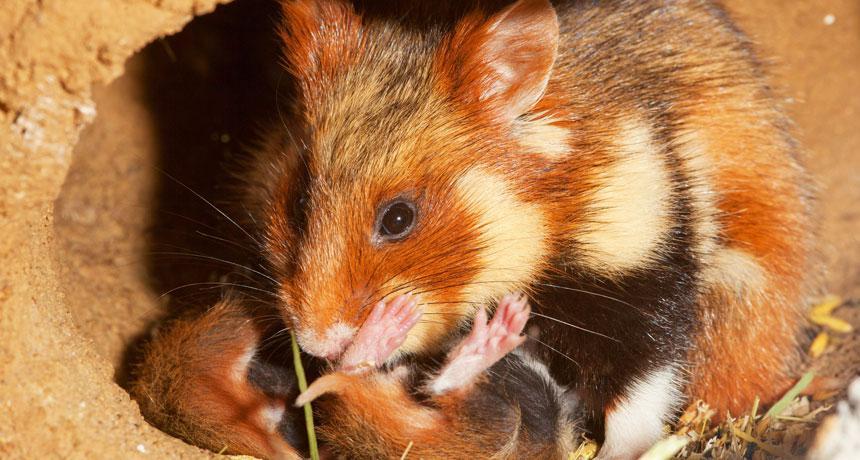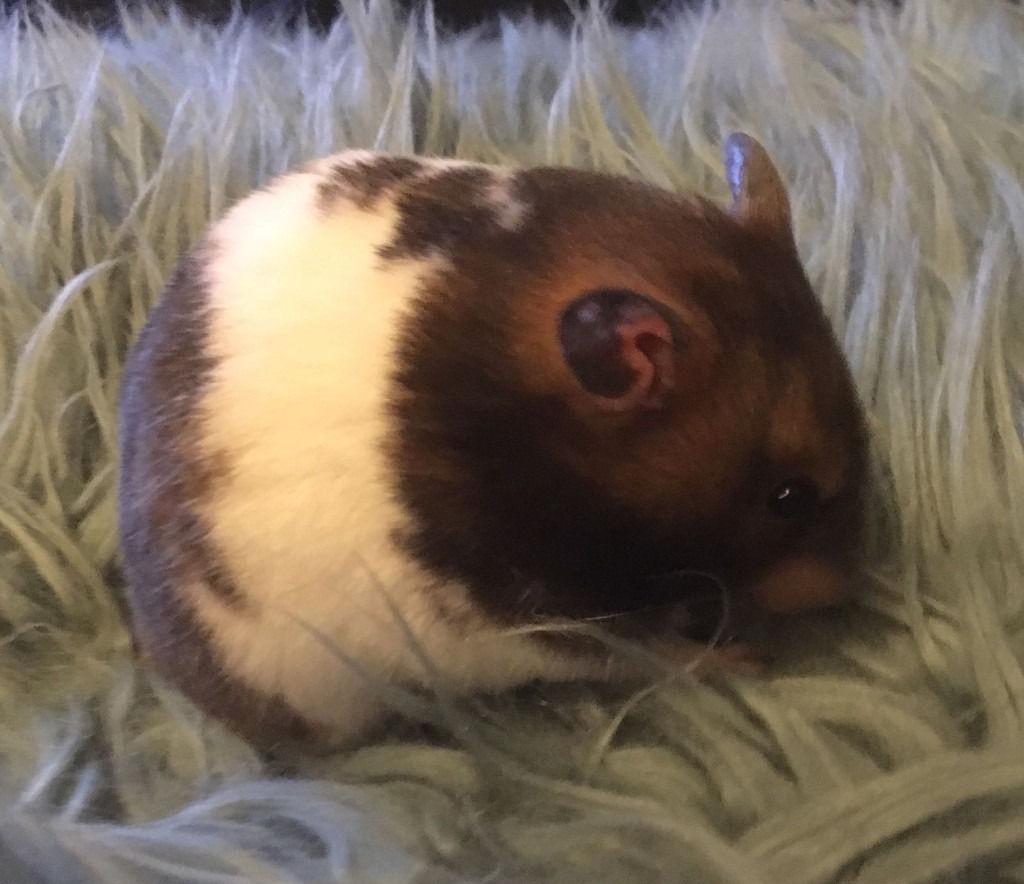The first image is the image on the left, the second image is the image on the right. Evaluate the accuracy of this statement regarding the images: "There are 3 hamsters in the image pair". Is it true? Answer yes or no. Yes. The first image is the image on the left, the second image is the image on the right. For the images shown, is this caption "There is a single animal in one image and at least two animals in the other." true? Answer yes or no. Yes. 